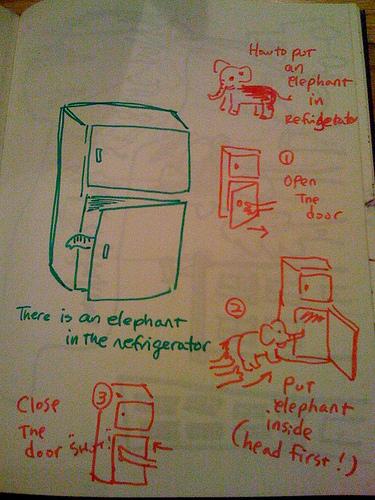Why would you put an elephant in a fridge?
Answer briefly. Joke. Why would someone plan to attempt to put an elephant in a refrigerator?
Concise answer only. Stupid. Are these instructions all in one color?
Concise answer only. No. 